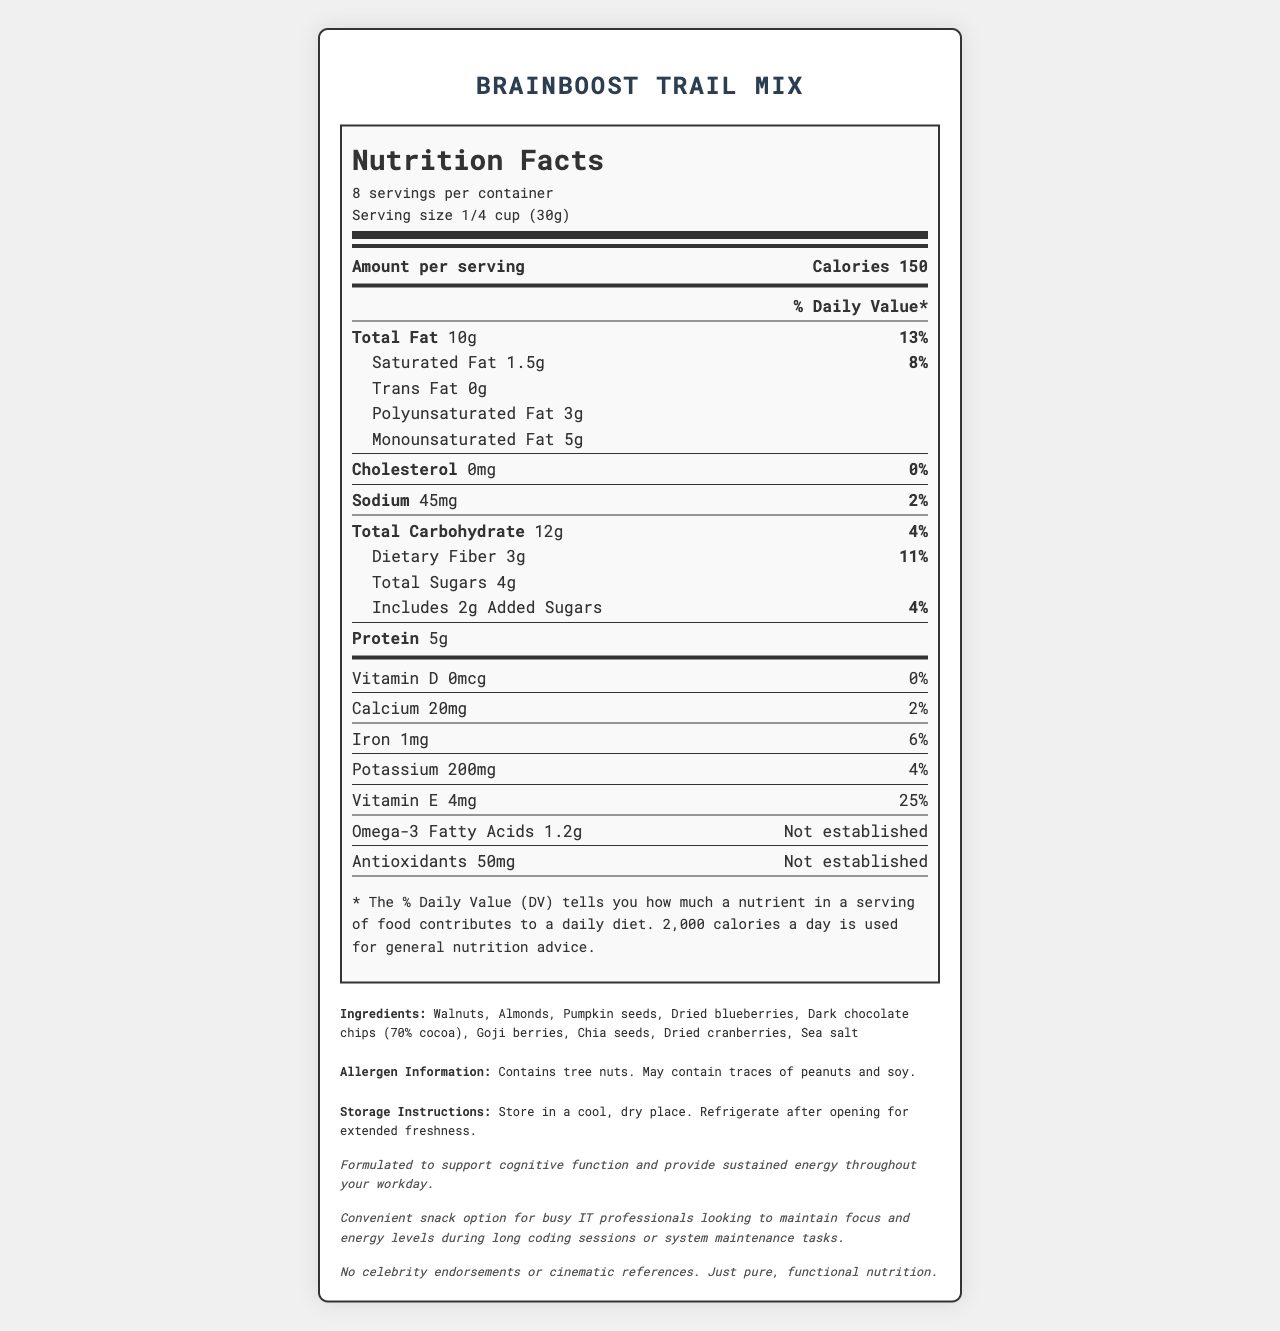what is the serving size? The serving size is listed at the top of the document in the serving info section.
Answer: 1/4 cup (30g) how many servings are in a container? The document states that there are 8 servings per container.
Answer: 8 what is the total fat per serving? The total fat amount per serving is 10g as indicated in the nutrition facts.
Answer: 10g how many grams of protein are in one serving? The document lists protein content as 5g per serving.
Answer: 5g what ingredient might someone with a peanut allergy be concerned about? The allergen information states the product may contain traces of peanuts.
Answer: May contain traces of peanuts what is the daily value percentage for vitamin E? The daily value percentage for vitamin E is 25%, as shown under the nutrient facts.
Answer: 25% what is the total carbohydrate amount per serving? The total carbohydrate amount per serving is 12g according to the nutrition facts.
Answer: 12g how much omega-3 fatty acids are there in a serving? Omega-3 fatty acids amount to 1.2g per serving according to the nutrition label.
Answer: 1.2g what is the primary claim of the BrainBoost Trail Mix? The efficiency claim states that it is formulated to support cognitive function and provide sustained energy.
Answer: Formulated to support cognitive function and provide sustained energy throughout your workday. how many grams of dietary fiber does one serving contain? One serving contains 3 grams of dietary fiber, according to the nutrition facts label.
Answer: 3g choose the correct amount of calories per serving: A. 130 B. 150 C. 160 D. 180 The document states that each serving contains 150 calories.
Answer: B how much vitamin D is in one serving? A. 0mcg B. 2mcg C. 4mcg D. 6mcg The document states that one serving contains 0mcg of vitamin D.
Answer: A does this product contain any cholesterol? According to the nutrition facts, the product contains 0mg of cholesterol, which translates to 0%.
Answer: No summarize the main idea of the BrainBoost Trail Mix nutrition facts label. The product focuses on providing balanced nutrition with an emphasis on brain health, supported by detailed nutritional and ingredient information.
Answer: BrainBoost Trail Mix is a nutrient-dense snack designed to support cognitive function and provide sustained energy, featuring omega-3 fatty acids, antioxidants, and a range of vitamins and minerals. The label details the nutritional content per serving, ingredient list, and storage instructions. what is the manufacturing process for the BrainBoost Trail Mix? The document provides detailed nutritional information but does not include any details about the manufacturing process.
Answer: Not enough information 